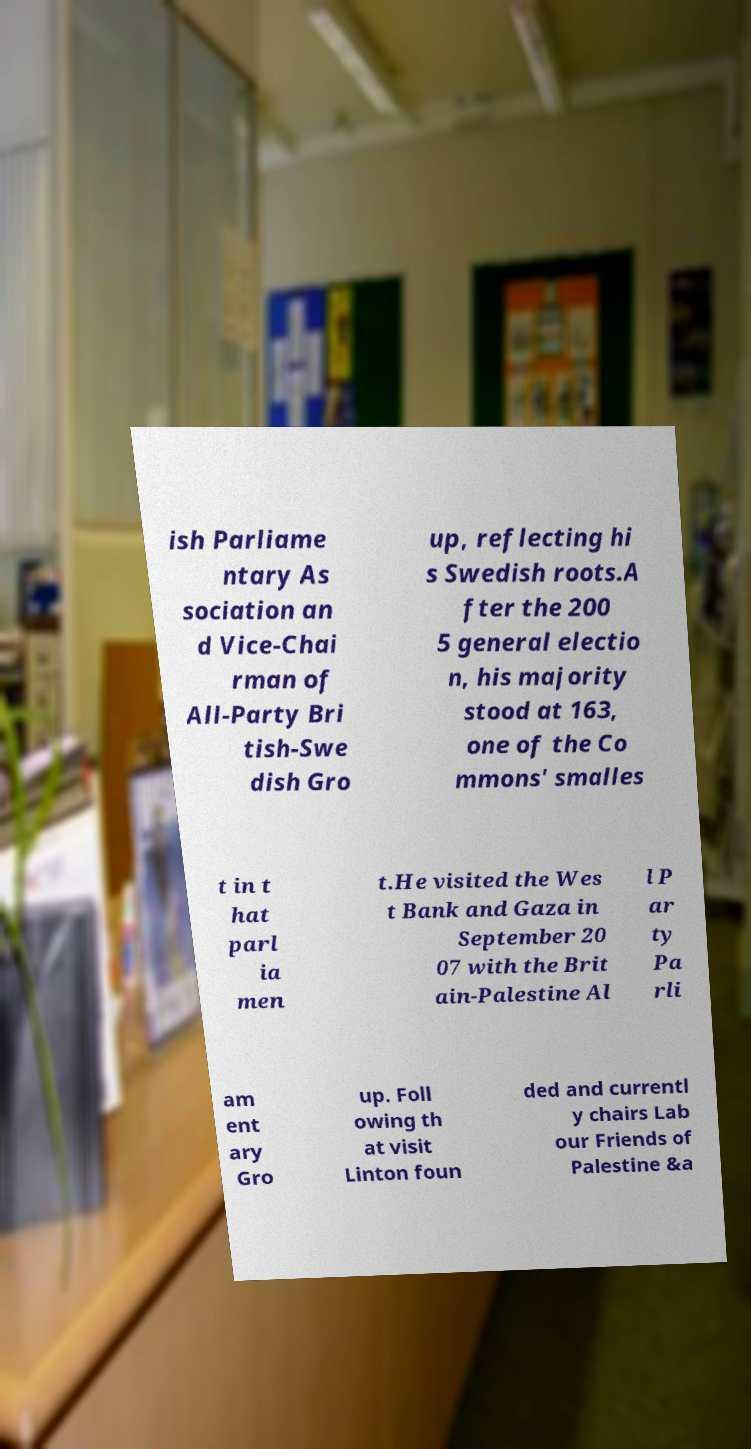Please read and relay the text visible in this image. What does it say? ish Parliame ntary As sociation an d Vice-Chai rman of All-Party Bri tish-Swe dish Gro up, reflecting hi s Swedish roots.A fter the 200 5 general electio n, his majority stood at 163, one of the Co mmons' smalles t in t hat parl ia men t.He visited the Wes t Bank and Gaza in September 20 07 with the Brit ain-Palestine Al l P ar ty Pa rli am ent ary Gro up. Foll owing th at visit Linton foun ded and currentl y chairs Lab our Friends of Palestine &a 